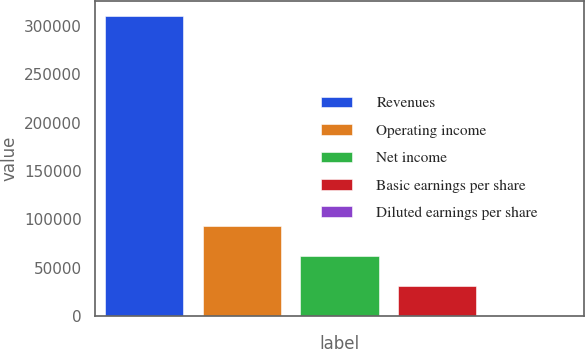Convert chart to OTSL. <chart><loc_0><loc_0><loc_500><loc_500><bar_chart><fcel>Revenues<fcel>Operating income<fcel>Net income<fcel>Basic earnings per share<fcel>Diluted earnings per share<nl><fcel>310641<fcel>93192.6<fcel>62128.6<fcel>31064.5<fcel>0.5<nl></chart> 